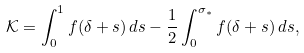Convert formula to latex. <formula><loc_0><loc_0><loc_500><loc_500>\mathcal { K } = \int _ { 0 } ^ { 1 } f ( \delta + s ) \, d s - \frac { 1 } { 2 } \int _ { 0 } ^ { \sigma _ { * } } f ( \delta + s ) \, d s ,</formula> 